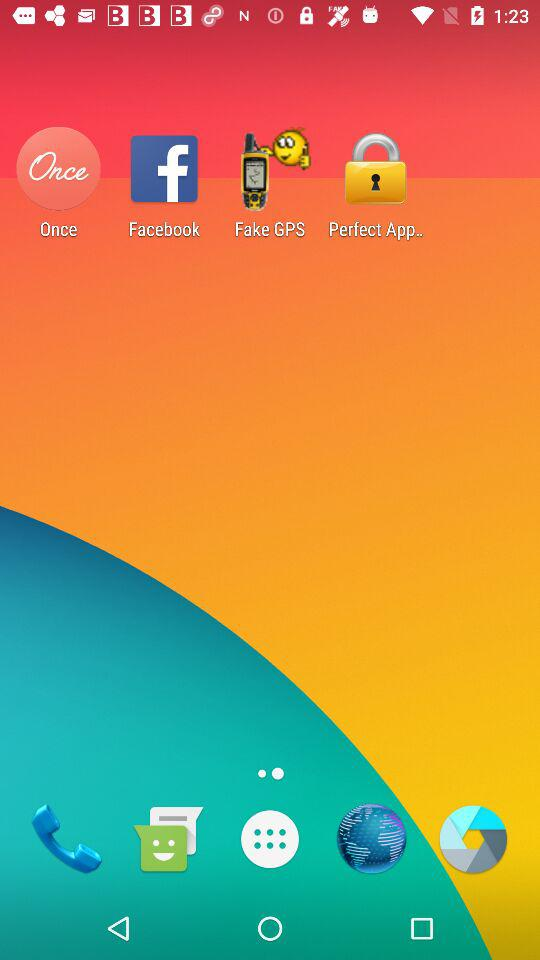How many apps are there on the app launcher?
Answer the question using a single word or phrase. 4 